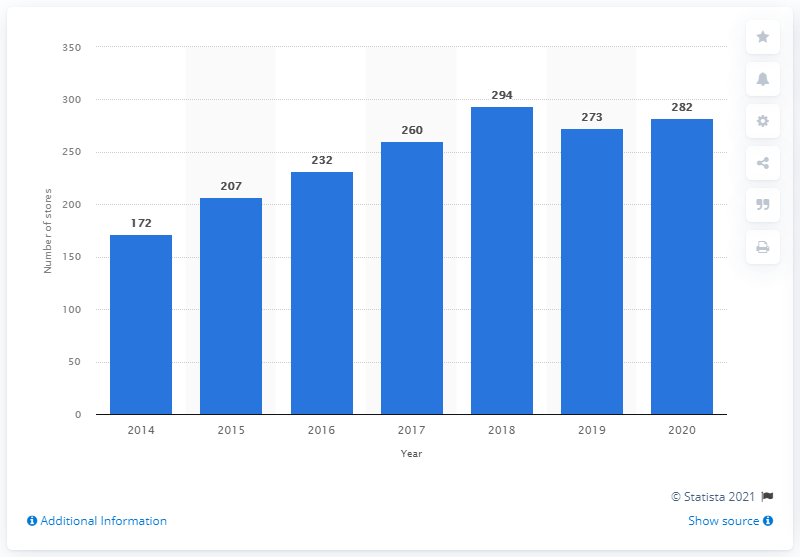Outline some significant characteristics in this image. In 2020, Moncler operated a total of 282 stores worldwide. 